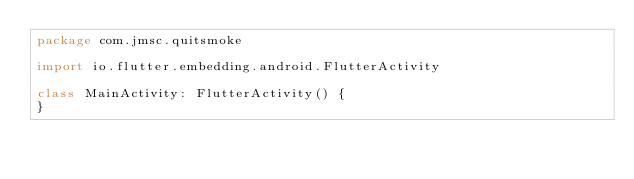<code> <loc_0><loc_0><loc_500><loc_500><_Kotlin_>package com.jmsc.quitsmoke

import io.flutter.embedding.android.FlutterActivity

class MainActivity: FlutterActivity() {
}
</code> 